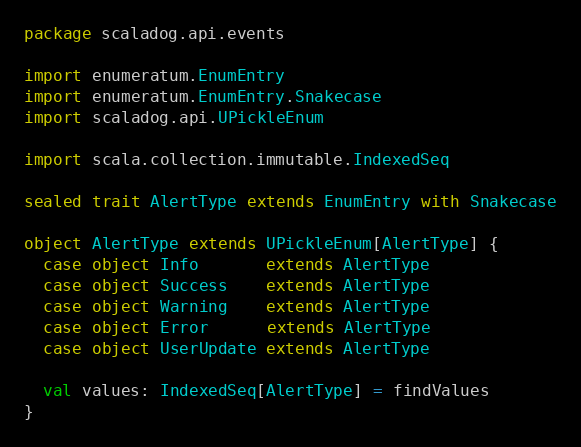<code> <loc_0><loc_0><loc_500><loc_500><_Scala_>package scaladog.api.events

import enumeratum.EnumEntry
import enumeratum.EnumEntry.Snakecase
import scaladog.api.UPickleEnum

import scala.collection.immutable.IndexedSeq

sealed trait AlertType extends EnumEntry with Snakecase

object AlertType extends UPickleEnum[AlertType] {
  case object Info       extends AlertType
  case object Success    extends AlertType
  case object Warning    extends AlertType
  case object Error      extends AlertType
  case object UserUpdate extends AlertType

  val values: IndexedSeq[AlertType] = findValues
}
</code> 